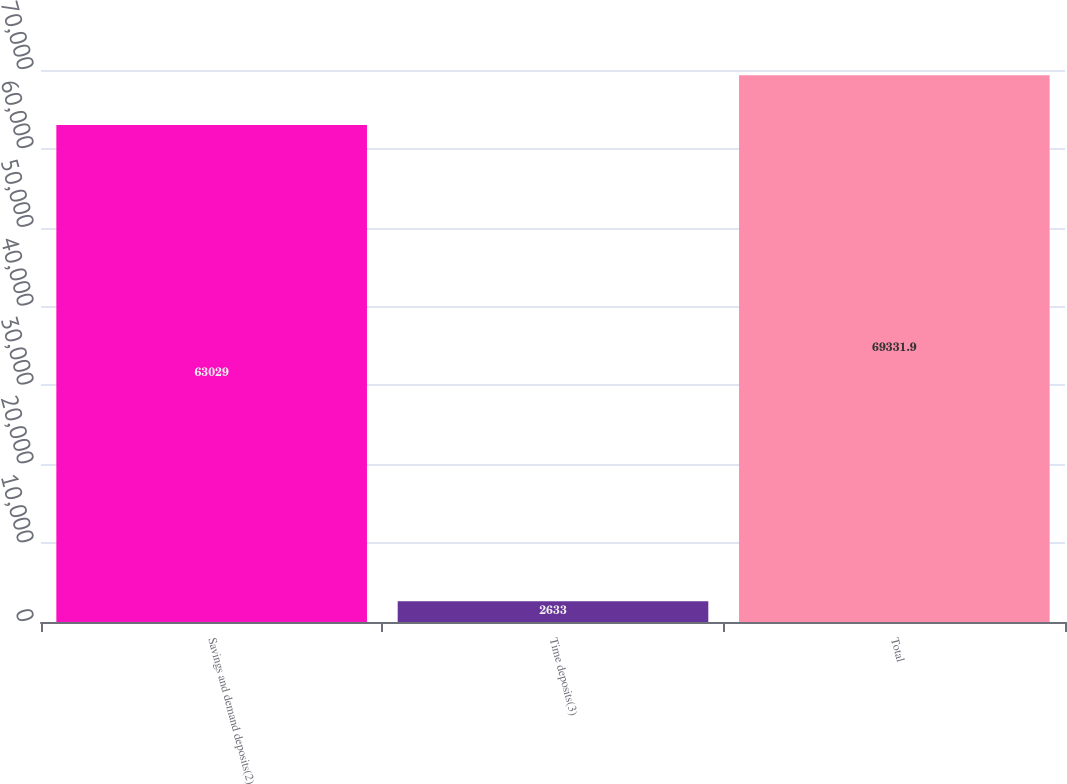Convert chart to OTSL. <chart><loc_0><loc_0><loc_500><loc_500><bar_chart><fcel>Savings and demand deposits(2)<fcel>Time deposits(3)<fcel>Total<nl><fcel>63029<fcel>2633<fcel>69331.9<nl></chart> 